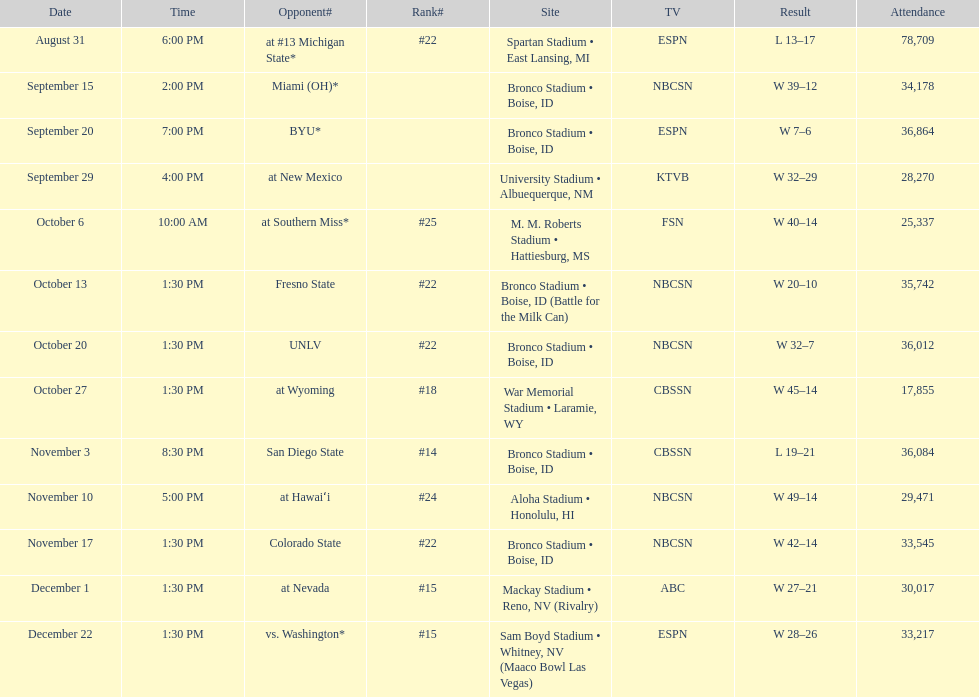What position did boise state hold after november 10th? #22. 